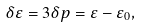Convert formula to latex. <formula><loc_0><loc_0><loc_500><loc_500>\delta \varepsilon = 3 \delta p = \varepsilon - \varepsilon _ { 0 } ,</formula> 